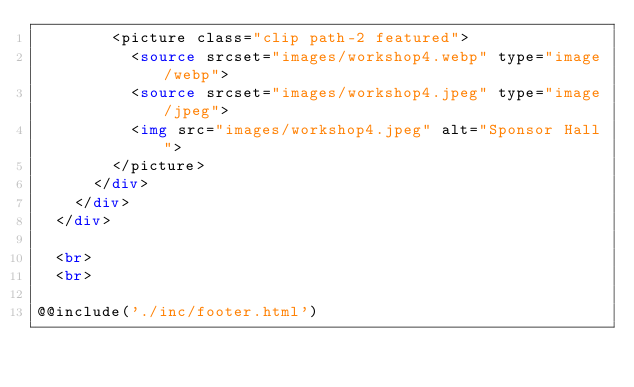<code> <loc_0><loc_0><loc_500><loc_500><_HTML_>        <picture class="clip path-2 featured">
          <source srcset="images/workshop4.webp" type="image/webp">
          <source srcset="images/workshop4.jpeg" type="image/jpeg">
          <img src="images/workshop4.jpeg" alt="Sponsor Hall">
        </picture>
      </div>
    </div>
  </div>

  <br>
  <br>

@@include('./inc/footer.html')
</code> 